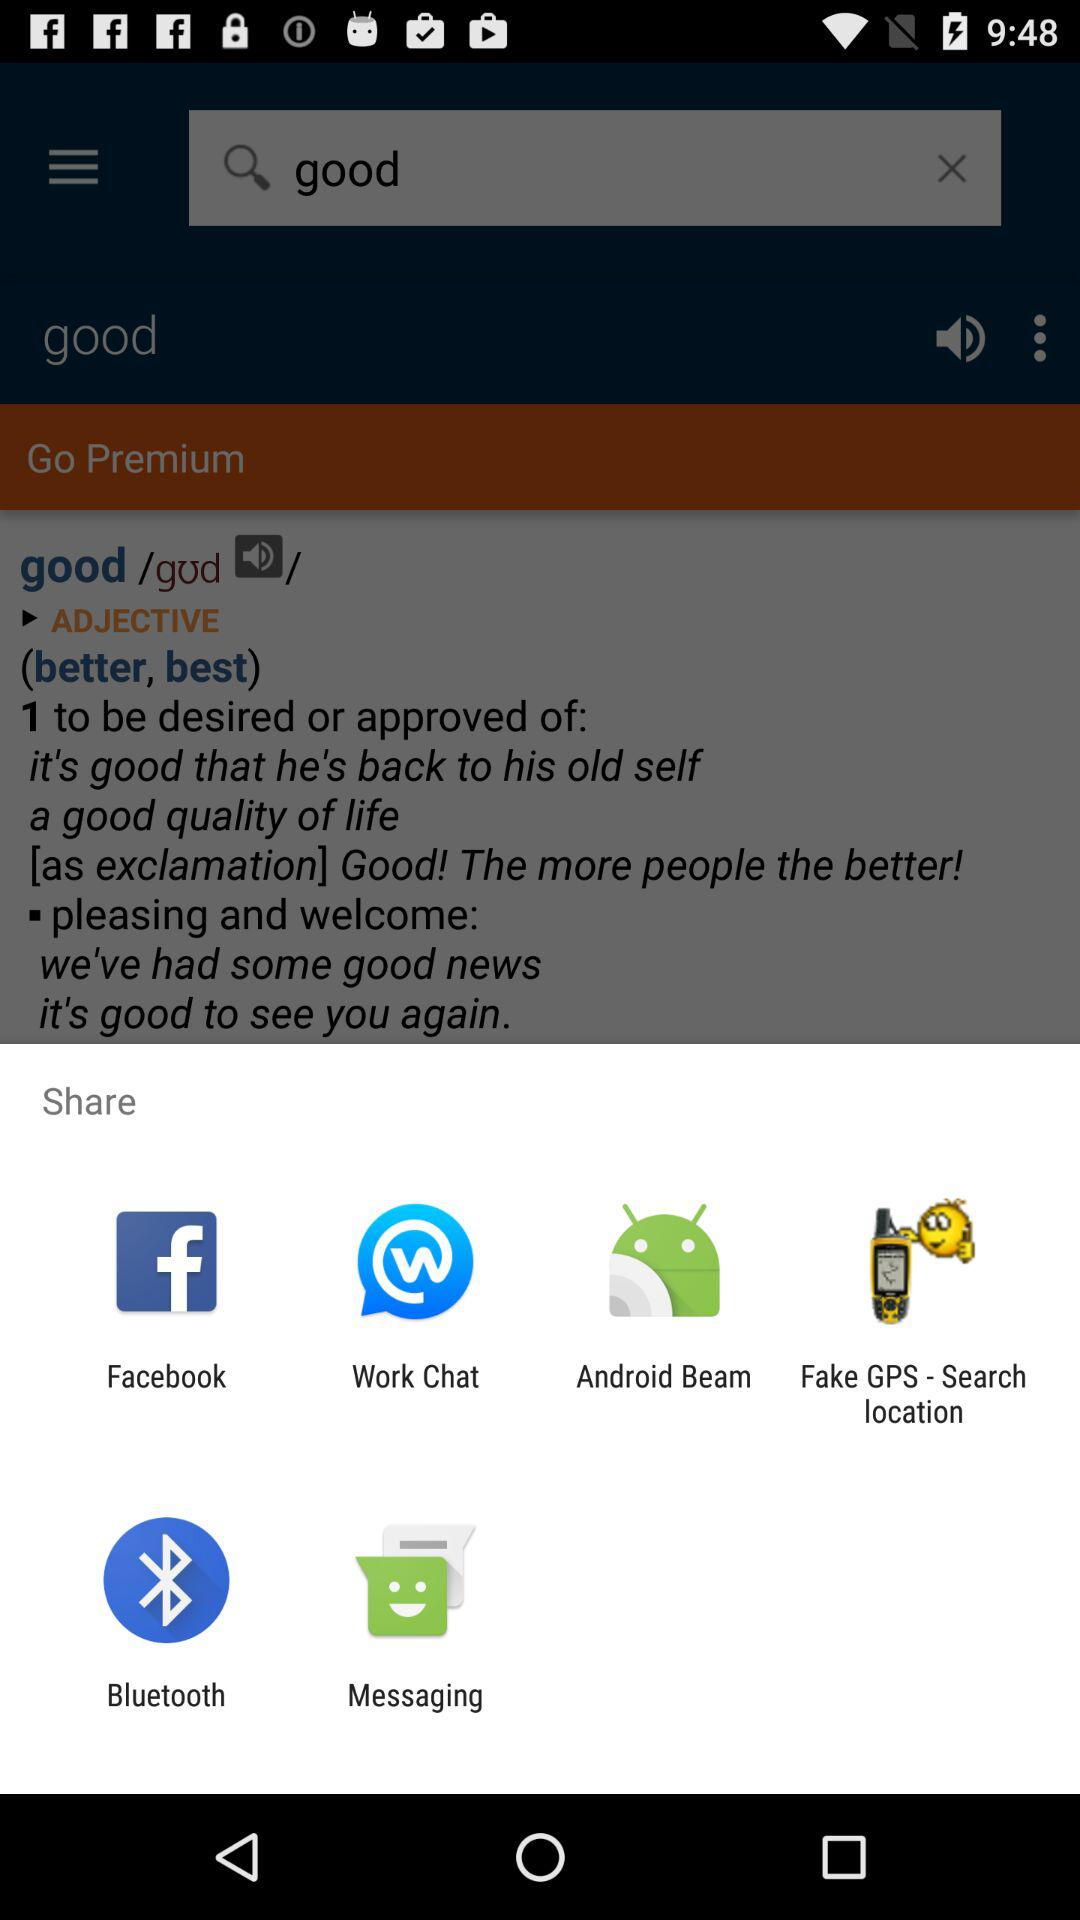Which applications can be used to share? The applications that can be used to share are "Facebook", "Work Chat", "Android Beam", "Fake GPS - Search location", "Bluetooth" and "Messaging". 